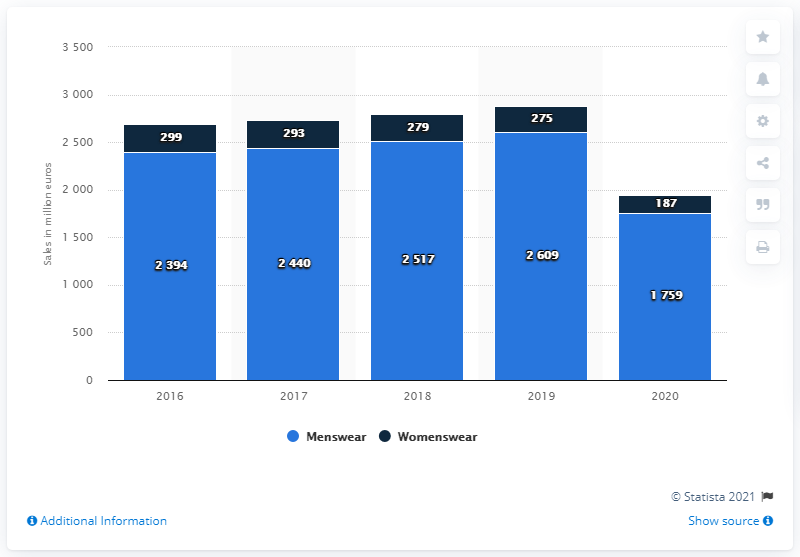Draw attention to some important aspects in this diagram. In 2020, the sales of Hugo Boss's menswear category were 1,759. 